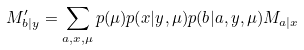Convert formula to latex. <formula><loc_0><loc_0><loc_500><loc_500>M ^ { \prime } _ { b | y } = \sum _ { a , x , \mu } p ( \mu ) p ( x | y , \mu ) p ( b | a , y , \mu ) M _ { a | x }</formula> 